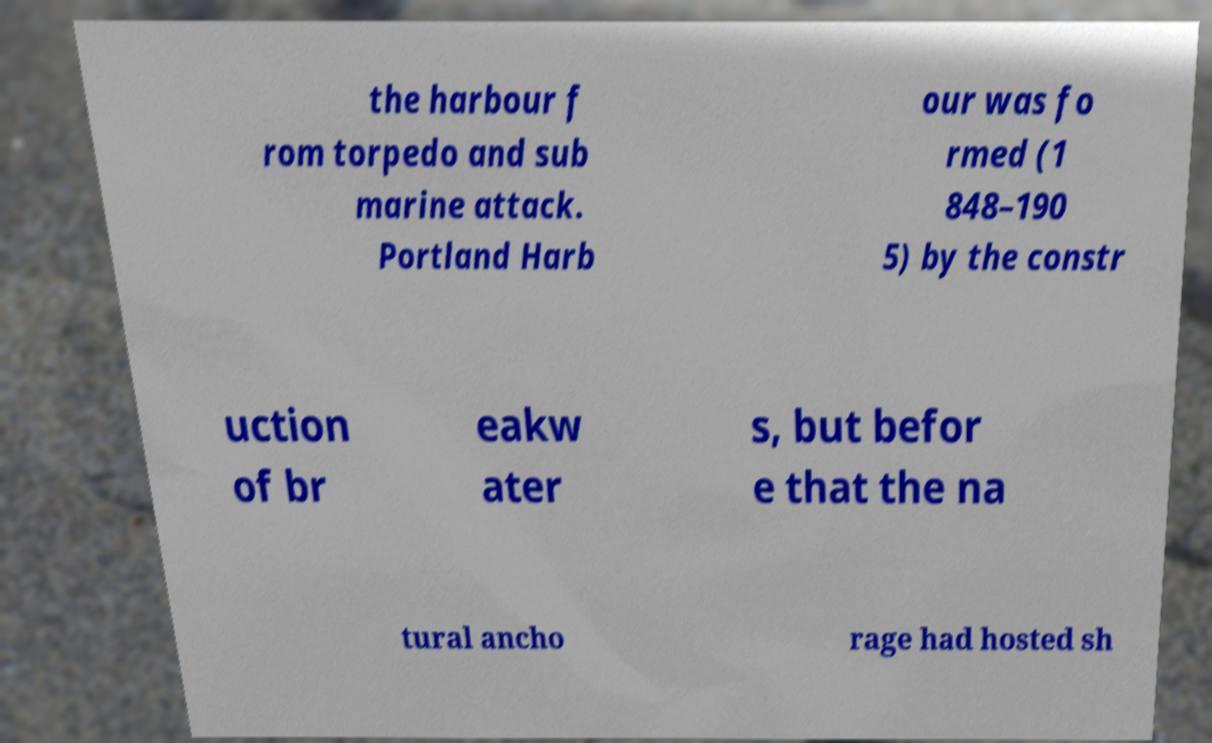Could you assist in decoding the text presented in this image and type it out clearly? the harbour f rom torpedo and sub marine attack. Portland Harb our was fo rmed (1 848–190 5) by the constr uction of br eakw ater s, but befor e that the na tural ancho rage had hosted sh 